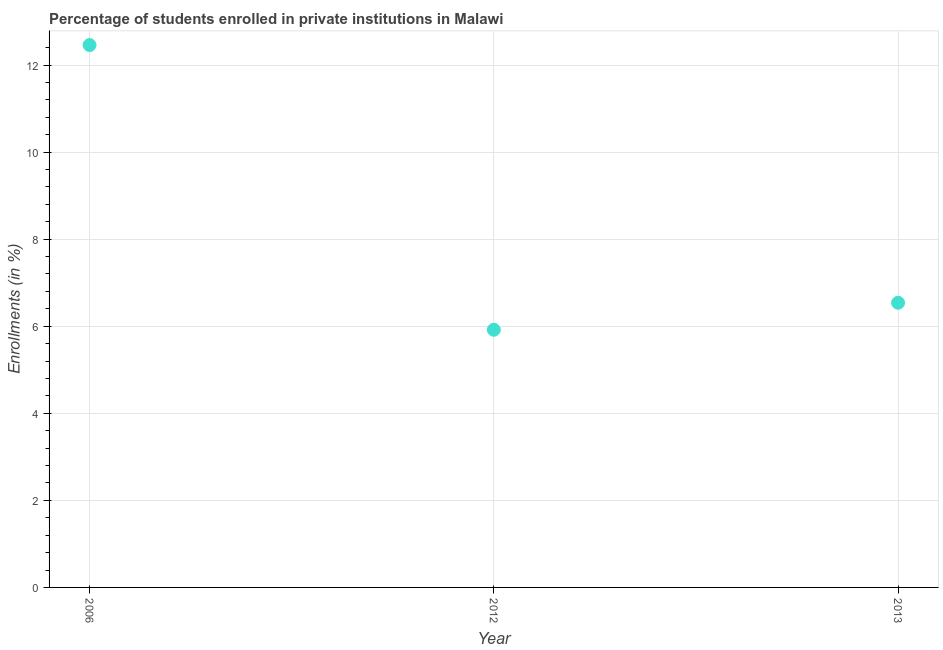What is the enrollments in private institutions in 2012?
Keep it short and to the point. 5.92. Across all years, what is the maximum enrollments in private institutions?
Your response must be concise. 12.46. Across all years, what is the minimum enrollments in private institutions?
Keep it short and to the point. 5.92. In which year was the enrollments in private institutions minimum?
Your answer should be very brief. 2012. What is the sum of the enrollments in private institutions?
Keep it short and to the point. 24.92. What is the difference between the enrollments in private institutions in 2006 and 2012?
Your answer should be very brief. 6.54. What is the average enrollments in private institutions per year?
Keep it short and to the point. 8.31. What is the median enrollments in private institutions?
Provide a short and direct response. 6.54. Do a majority of the years between 2006 and 2012 (inclusive) have enrollments in private institutions greater than 6.8 %?
Provide a short and direct response. No. What is the ratio of the enrollments in private institutions in 2006 to that in 2012?
Keep it short and to the point. 2.1. Is the difference between the enrollments in private institutions in 2006 and 2013 greater than the difference between any two years?
Your response must be concise. No. What is the difference between the highest and the second highest enrollments in private institutions?
Give a very brief answer. 5.92. Is the sum of the enrollments in private institutions in 2006 and 2013 greater than the maximum enrollments in private institutions across all years?
Provide a succinct answer. Yes. What is the difference between the highest and the lowest enrollments in private institutions?
Your response must be concise. 6.54. Does the enrollments in private institutions monotonically increase over the years?
Ensure brevity in your answer.  No. What is the difference between two consecutive major ticks on the Y-axis?
Make the answer very short. 2. Are the values on the major ticks of Y-axis written in scientific E-notation?
Keep it short and to the point. No. What is the title of the graph?
Your response must be concise. Percentage of students enrolled in private institutions in Malawi. What is the label or title of the X-axis?
Your answer should be compact. Year. What is the label or title of the Y-axis?
Your answer should be compact. Enrollments (in %). What is the Enrollments (in %) in 2006?
Provide a succinct answer. 12.46. What is the Enrollments (in %) in 2012?
Your answer should be compact. 5.92. What is the Enrollments (in %) in 2013?
Make the answer very short. 6.54. What is the difference between the Enrollments (in %) in 2006 and 2012?
Your response must be concise. 6.54. What is the difference between the Enrollments (in %) in 2006 and 2013?
Provide a succinct answer. 5.92. What is the difference between the Enrollments (in %) in 2012 and 2013?
Give a very brief answer. -0.62. What is the ratio of the Enrollments (in %) in 2006 to that in 2012?
Give a very brief answer. 2.1. What is the ratio of the Enrollments (in %) in 2006 to that in 2013?
Your answer should be very brief. 1.91. What is the ratio of the Enrollments (in %) in 2012 to that in 2013?
Give a very brief answer. 0.91. 